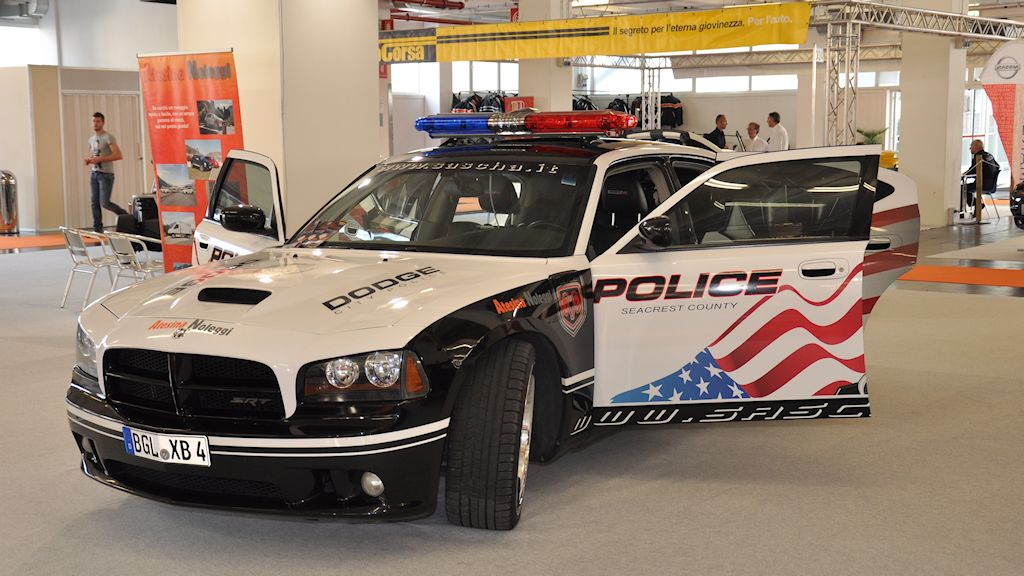Describe a realistic scenario where this police vehicle enhances community relationships. During a community fair, this police vehicle is parked prominently at the event, attracting residents with its eye-catching design. Officers standing by invite children and families to explore the car, explaining the various features and how they help keep the community safe. This informal, friendly interaction helps demystify law enforcement, encouraging positive dialogue between the police and the public. The officers also hand out safety brochures and engage in casual conversations, building rapport and trust. The vehicle, in this setting, serves as a bridge between the police force and the community, fostering a sense of partnership and mutual respect. 